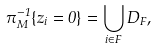Convert formula to latex. <formula><loc_0><loc_0><loc_500><loc_500>\pi _ { M } ^ { - 1 } \{ z _ { i } = 0 \} = \bigcup _ { i \in F } D _ { F } ,</formula> 